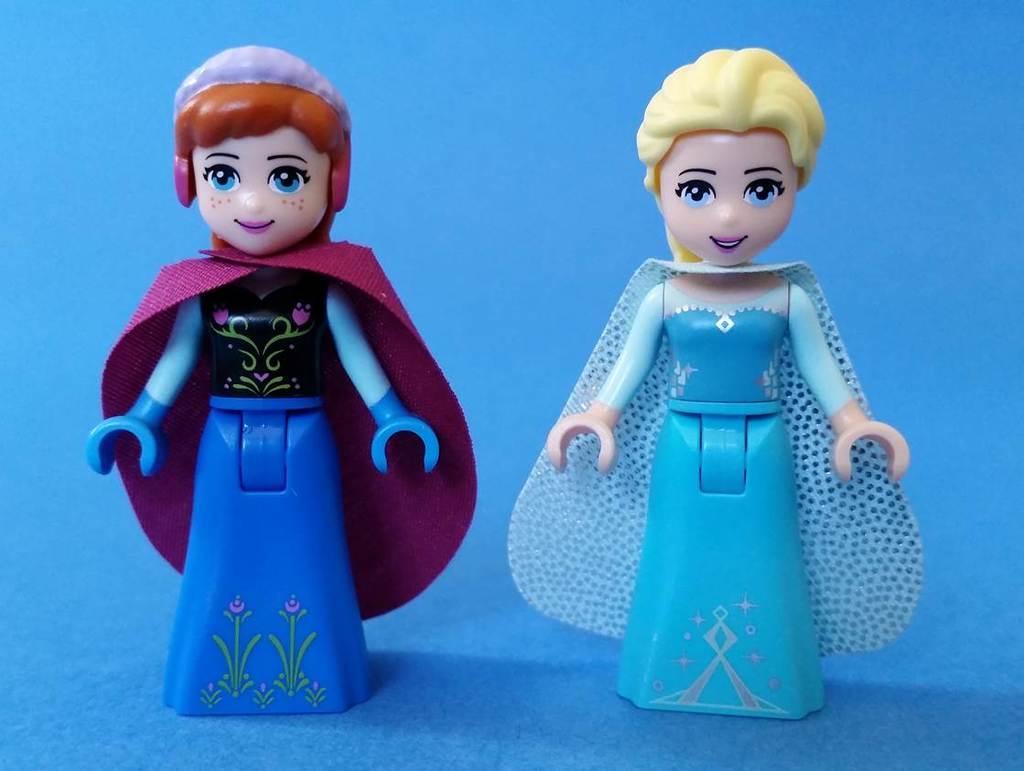How would you summarize this image in a sentence or two? In this picture there are two toys on a blue surface. 